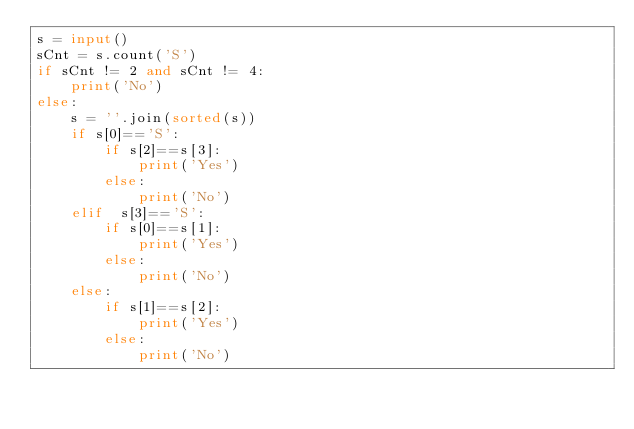<code> <loc_0><loc_0><loc_500><loc_500><_Python_>s = input()
sCnt = s.count('S')
if sCnt != 2 and sCnt != 4:
    print('No')
else:
    s = ''.join(sorted(s))
    if s[0]=='S':
        if s[2]==s[3]:
            print('Yes')
        else:
            print('No')
    elif  s[3]=='S':
        if s[0]==s[1]:
            print('Yes')
        else:
            print('No')
    else:
        if s[1]==s[2]:
            print('Yes')
        else:
            print('No')</code> 